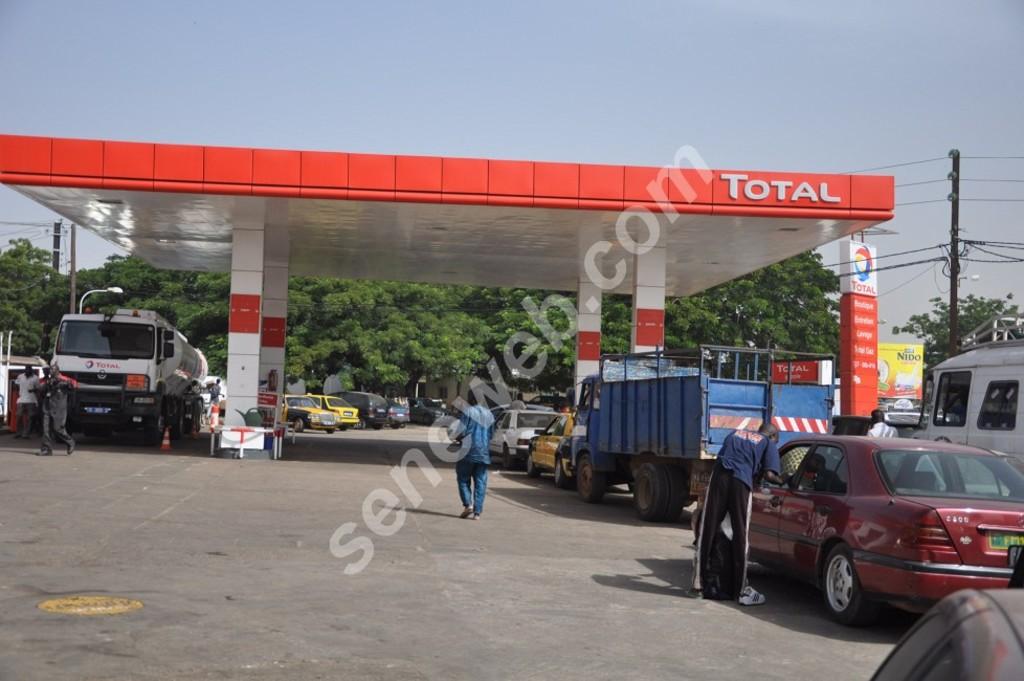Whats the name of the gas station?
Offer a very short reply. Total. 